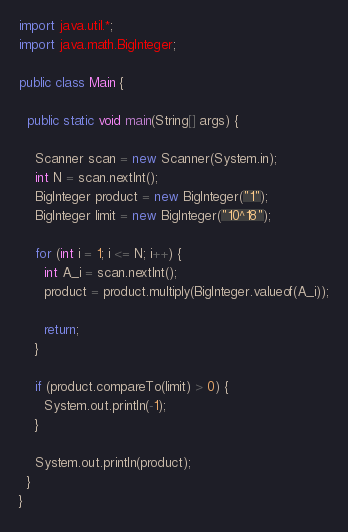Convert code to text. <code><loc_0><loc_0><loc_500><loc_500><_Java_>import java.util.*;
import java.math.BigInteger;
 
public class Main {
  
  public static void main(String[] args) {
    
    Scanner scan = new Scanner(System.in);
    int N = scan.nextInt();
    BigInteger product = new BigInteger("1");
    BigInteger limit = new BigInteger("10^18"); 
    
    for (int i = 1; i <= N; i++) {
      int A_i = scan.nextInt();
      product = product.multiply(BigInteger.valueof(A_i));
      
      return;
    }
    
    if (product.compareTo(limit) > 0) {
      System.out.println(-1);
    }
	
	System.out.println(product);
  }
}</code> 